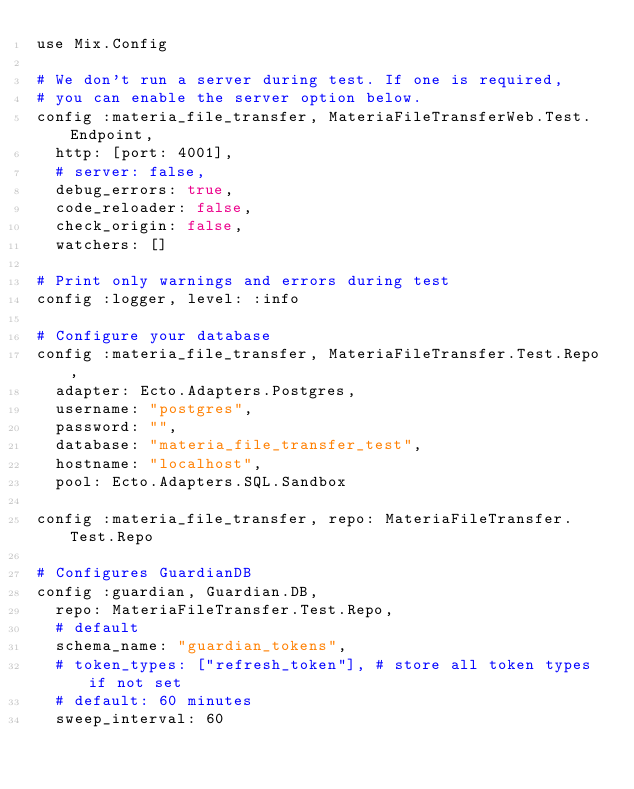Convert code to text. <code><loc_0><loc_0><loc_500><loc_500><_Elixir_>use Mix.Config

# We don't run a server during test. If one is required,
# you can enable the server option below.
config :materia_file_transfer, MateriaFileTransferWeb.Test.Endpoint,
  http: [port: 4001],
  # server: false,
  debug_errors: true,
  code_reloader: false,
  check_origin: false,
  watchers: []

# Print only warnings and errors during test
config :logger, level: :info

# Configure your database
config :materia_file_transfer, MateriaFileTransfer.Test.Repo,
  adapter: Ecto.Adapters.Postgres,
  username: "postgres",
  password: "",
  database: "materia_file_transfer_test",
  hostname: "localhost",
  pool: Ecto.Adapters.SQL.Sandbox

config :materia_file_transfer, repo: MateriaFileTransfer.Test.Repo

# Configures GuardianDB
config :guardian, Guardian.DB,
  repo: MateriaFileTransfer.Test.Repo,
  # default
  schema_name: "guardian_tokens",
  # token_types: ["refresh_token"], # store all token types if not set
  # default: 60 minutes
  sweep_interval: 60
</code> 